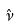<formula> <loc_0><loc_0><loc_500><loc_500>\hat { \nu }</formula> 